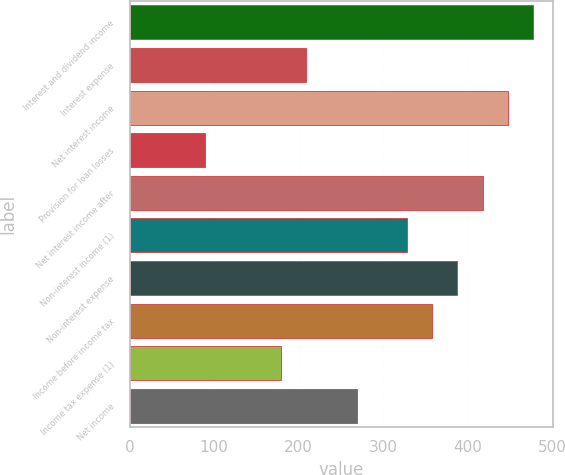Convert chart. <chart><loc_0><loc_0><loc_500><loc_500><bar_chart><fcel>Interest and dividend income<fcel>Interest expense<fcel>Net interest income<fcel>Provision for loan losses<fcel>Net interest income after<fcel>Non-interest income (1)<fcel>Non-interest expense<fcel>Income before income tax<fcel>Income tax expense (1)<fcel>Net income<nl><fcel>477.45<fcel>208.98<fcel>447.62<fcel>89.66<fcel>417.79<fcel>328.3<fcel>387.96<fcel>358.13<fcel>179.15<fcel>268.64<nl></chart> 